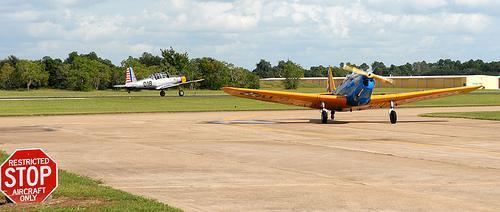How many planes in the photo have yellow wings?
Give a very brief answer. 1. 